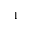Convert formula to latex. <formula><loc_0><loc_0><loc_500><loc_500>^ { 1 }</formula> 